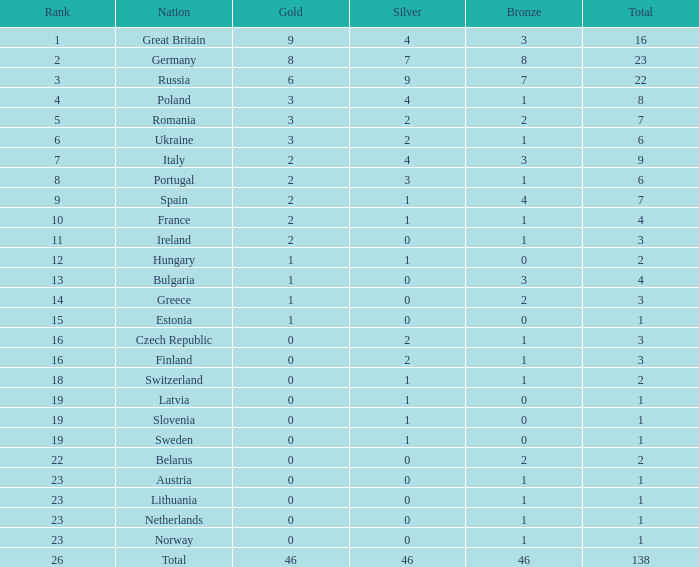In which nation does the total exceed 1, bronze medals are fewer than 3, silver medals are more than 2, and gold medals are greater than 2? Poland. 